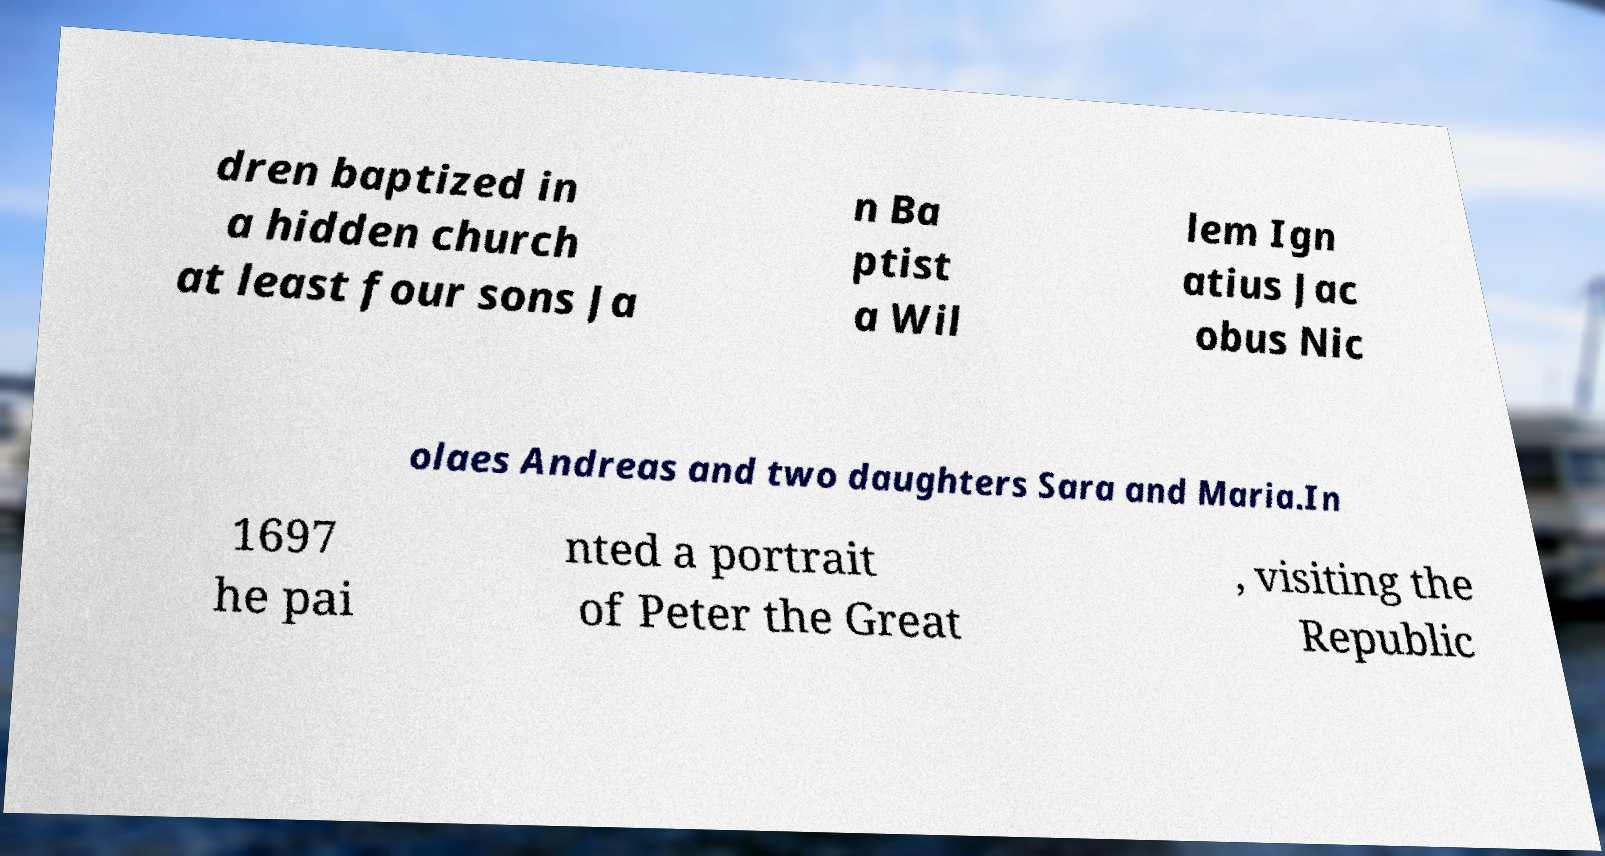What messages or text are displayed in this image? I need them in a readable, typed format. dren baptized in a hidden church at least four sons Ja n Ba ptist a Wil lem Ign atius Jac obus Nic olaes Andreas and two daughters Sara and Maria.In 1697 he pai nted a portrait of Peter the Great , visiting the Republic 